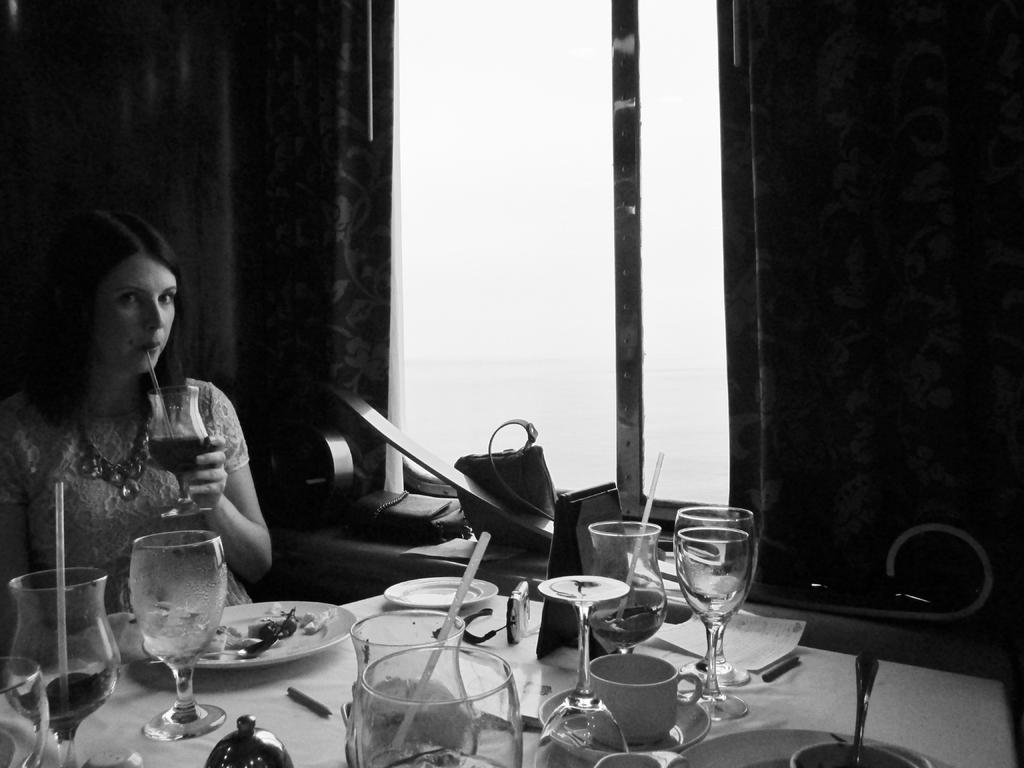What is the woman doing in the image? The woman is sitting near a table in the image. What objects are on the table in the image? There is a glass, a plate, food, a straw, a bag, a card, a cup, a saucer, a paper, and a pen on the table in the image. Can you describe the window and its surroundings in the image? There is a window in the background of the image, and it has a curtain associated with it. What type of twist can be seen in the image? There is no twist present in the image. What is the woman using to cook the food on the table? The image does not show the woman cooking or using any pot to cook the food; she is simply sitting near the table with various objects on it. 